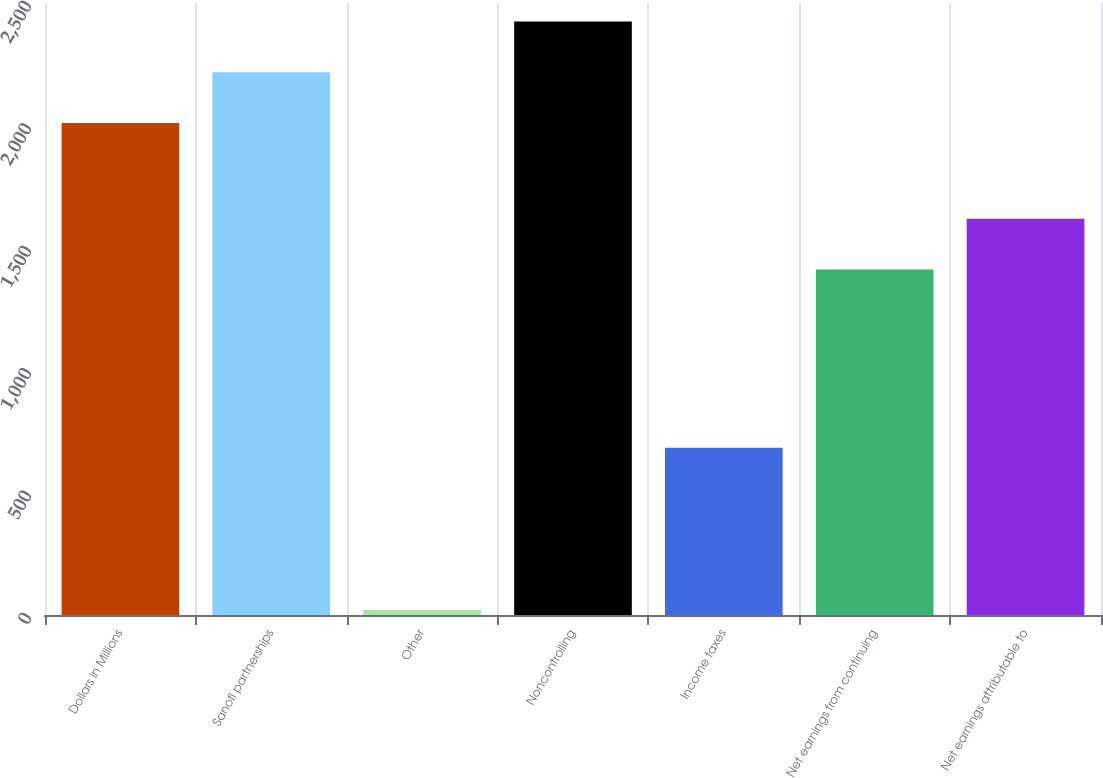Convert chart to OTSL. <chart><loc_0><loc_0><loc_500><loc_500><bar_chart><fcel>Dollars in Millions<fcel>Sanofi partnerships<fcel>Other<fcel>Noncontrolling<fcel>Income taxes<fcel>Net earnings from continuing<fcel>Net earnings attributable to<nl><fcel>2010<fcel>2217.4<fcel>20<fcel>2424.8<fcel>683<fcel>1411<fcel>1618.4<nl></chart> 